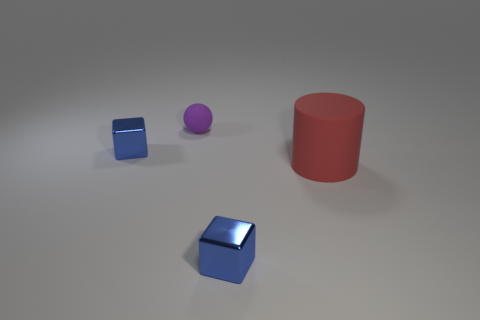What color is the ball that is made of the same material as the cylinder?
Offer a very short reply. Purple. How many big things are either balls or cylinders?
Offer a terse response. 1. How many purple spheres are on the left side of the large object?
Make the answer very short. 1. How many shiny things are big yellow things or purple things?
Keep it short and to the point. 0. There is a shiny thing in front of the tiny object that is left of the tiny purple rubber sphere; is there a small object that is left of it?
Offer a terse response. Yes. The ball is what color?
Your answer should be very brief. Purple. There is a object in front of the cylinder; is its shape the same as the large rubber object?
Provide a succinct answer. No. How many things are either purple rubber things or shiny things that are behind the red thing?
Your answer should be compact. 2. Does the small object that is on the left side of the ball have the same material as the purple sphere?
Your answer should be compact. No. Is there anything else that is the same size as the red cylinder?
Your answer should be compact. No. 